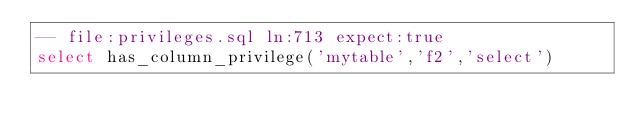Convert code to text. <code><loc_0><loc_0><loc_500><loc_500><_SQL_>-- file:privileges.sql ln:713 expect:true
select has_column_privilege('mytable','f2','select')
</code> 